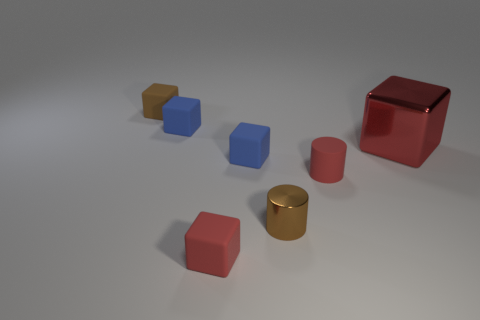Is there any other thing that has the same size as the red metal cube?
Provide a short and direct response. No. Are there more small green cylinders than red matte things?
Provide a short and direct response. No. What number of tiny objects are blue matte things or red rubber blocks?
Provide a succinct answer. 3. How many other objects are there of the same color as the big block?
Provide a succinct answer. 2. What number of small cubes have the same material as the large red cube?
Provide a short and direct response. 0. There is a cube that is in front of the tiny shiny thing; does it have the same color as the big object?
Keep it short and to the point. Yes. What number of brown objects are either large blocks or metal cylinders?
Give a very brief answer. 1. Are there any other things that are the same material as the large red cube?
Ensure brevity in your answer.  Yes. Is the material of the red thing left of the shiny cylinder the same as the big cube?
Ensure brevity in your answer.  No. How many things are green cylinders or tiny matte objects that are right of the red matte block?
Give a very brief answer. 2. 